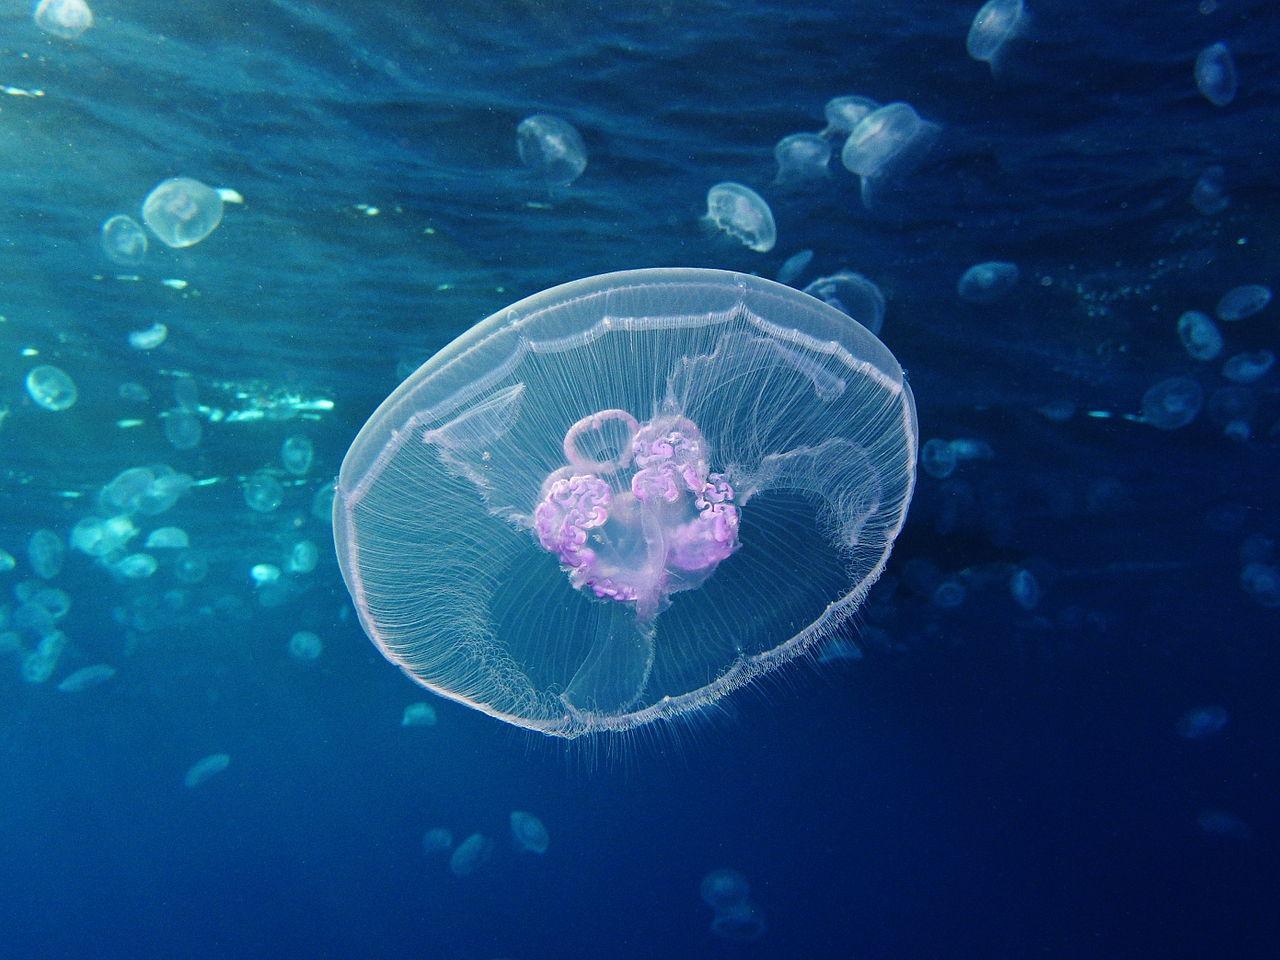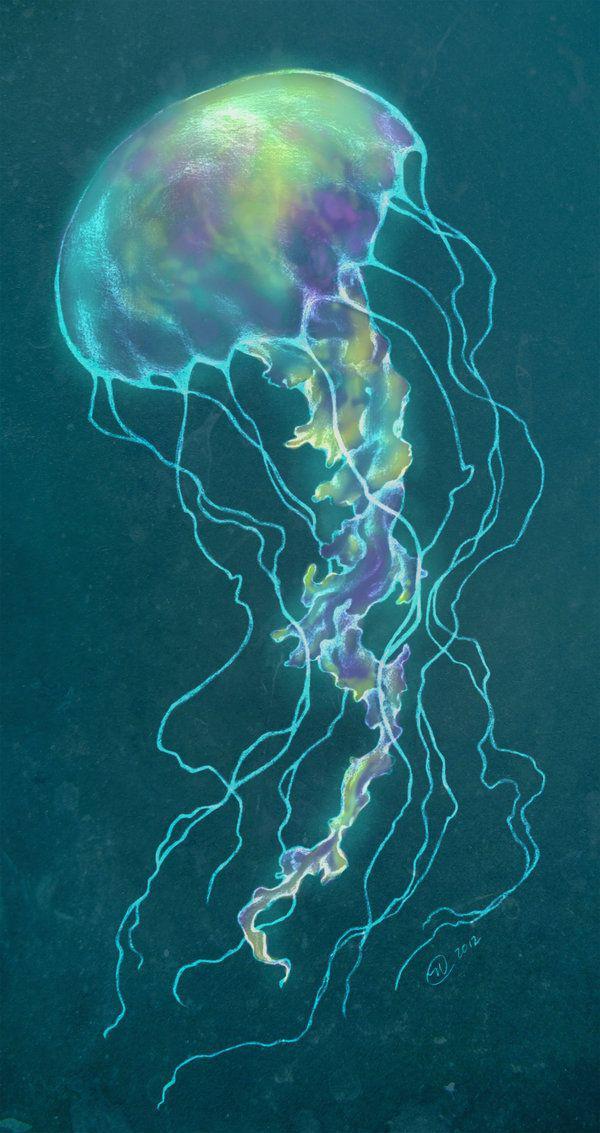The first image is the image on the left, the second image is the image on the right. Analyze the images presented: Is the assertion "The foreground of an image shows one pale, translucent, saucer-shaped jellyfish without long tendrils." valid? Answer yes or no. Yes. 